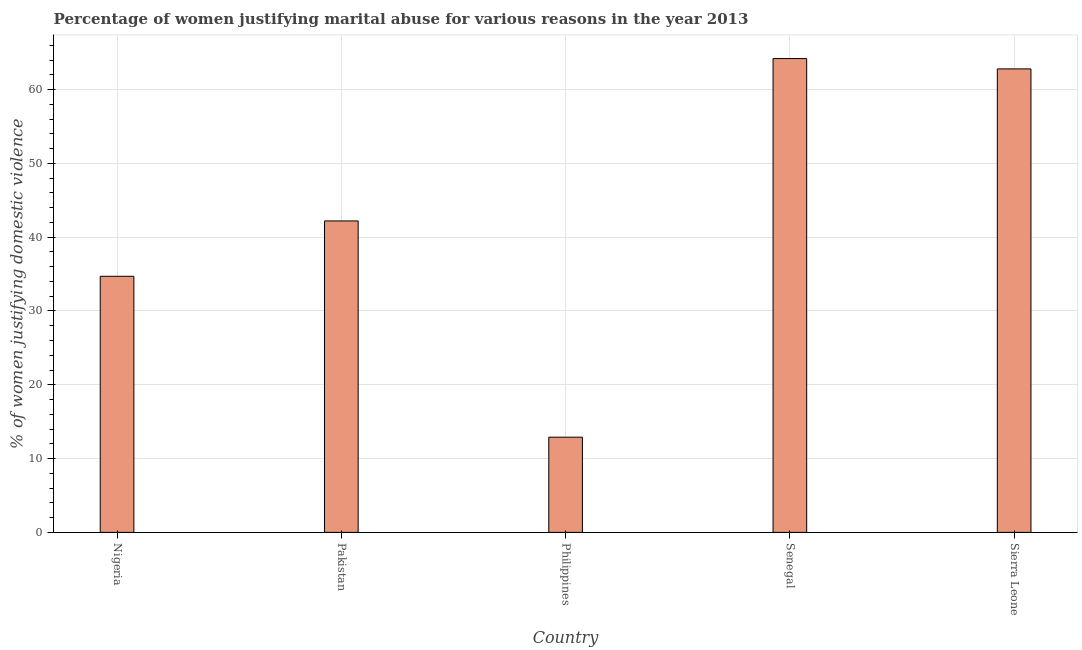Does the graph contain any zero values?
Offer a terse response. No. What is the title of the graph?
Your answer should be compact. Percentage of women justifying marital abuse for various reasons in the year 2013. What is the label or title of the Y-axis?
Keep it short and to the point. % of women justifying domestic violence. What is the percentage of women justifying marital abuse in Senegal?
Provide a short and direct response. 64.2. Across all countries, what is the maximum percentage of women justifying marital abuse?
Your answer should be compact. 64.2. Across all countries, what is the minimum percentage of women justifying marital abuse?
Keep it short and to the point. 12.9. In which country was the percentage of women justifying marital abuse maximum?
Give a very brief answer. Senegal. What is the sum of the percentage of women justifying marital abuse?
Keep it short and to the point. 216.8. What is the difference between the percentage of women justifying marital abuse in Nigeria and Senegal?
Your answer should be very brief. -29.5. What is the average percentage of women justifying marital abuse per country?
Offer a very short reply. 43.36. What is the median percentage of women justifying marital abuse?
Provide a short and direct response. 42.2. In how many countries, is the percentage of women justifying marital abuse greater than 38 %?
Make the answer very short. 3. What is the ratio of the percentage of women justifying marital abuse in Nigeria to that in Senegal?
Ensure brevity in your answer.  0.54. Is the percentage of women justifying marital abuse in Pakistan less than that in Senegal?
Provide a succinct answer. Yes. Is the difference between the percentage of women justifying marital abuse in Senegal and Sierra Leone greater than the difference between any two countries?
Make the answer very short. No. What is the difference between the highest and the lowest percentage of women justifying marital abuse?
Your answer should be very brief. 51.3. In how many countries, is the percentage of women justifying marital abuse greater than the average percentage of women justifying marital abuse taken over all countries?
Your answer should be compact. 2. How many bars are there?
Your answer should be compact. 5. Are all the bars in the graph horizontal?
Provide a succinct answer. No. What is the % of women justifying domestic violence in Nigeria?
Give a very brief answer. 34.7. What is the % of women justifying domestic violence in Pakistan?
Your answer should be compact. 42.2. What is the % of women justifying domestic violence in Senegal?
Ensure brevity in your answer.  64.2. What is the % of women justifying domestic violence of Sierra Leone?
Your answer should be very brief. 62.8. What is the difference between the % of women justifying domestic violence in Nigeria and Philippines?
Your answer should be compact. 21.8. What is the difference between the % of women justifying domestic violence in Nigeria and Senegal?
Give a very brief answer. -29.5. What is the difference between the % of women justifying domestic violence in Nigeria and Sierra Leone?
Keep it short and to the point. -28.1. What is the difference between the % of women justifying domestic violence in Pakistan and Philippines?
Offer a very short reply. 29.3. What is the difference between the % of women justifying domestic violence in Pakistan and Sierra Leone?
Give a very brief answer. -20.6. What is the difference between the % of women justifying domestic violence in Philippines and Senegal?
Ensure brevity in your answer.  -51.3. What is the difference between the % of women justifying domestic violence in Philippines and Sierra Leone?
Offer a very short reply. -49.9. What is the ratio of the % of women justifying domestic violence in Nigeria to that in Pakistan?
Keep it short and to the point. 0.82. What is the ratio of the % of women justifying domestic violence in Nigeria to that in Philippines?
Provide a short and direct response. 2.69. What is the ratio of the % of women justifying domestic violence in Nigeria to that in Senegal?
Provide a short and direct response. 0.54. What is the ratio of the % of women justifying domestic violence in Nigeria to that in Sierra Leone?
Make the answer very short. 0.55. What is the ratio of the % of women justifying domestic violence in Pakistan to that in Philippines?
Your response must be concise. 3.27. What is the ratio of the % of women justifying domestic violence in Pakistan to that in Senegal?
Ensure brevity in your answer.  0.66. What is the ratio of the % of women justifying domestic violence in Pakistan to that in Sierra Leone?
Offer a terse response. 0.67. What is the ratio of the % of women justifying domestic violence in Philippines to that in Senegal?
Your answer should be very brief. 0.2. What is the ratio of the % of women justifying domestic violence in Philippines to that in Sierra Leone?
Your answer should be compact. 0.2. What is the ratio of the % of women justifying domestic violence in Senegal to that in Sierra Leone?
Ensure brevity in your answer.  1.02. 